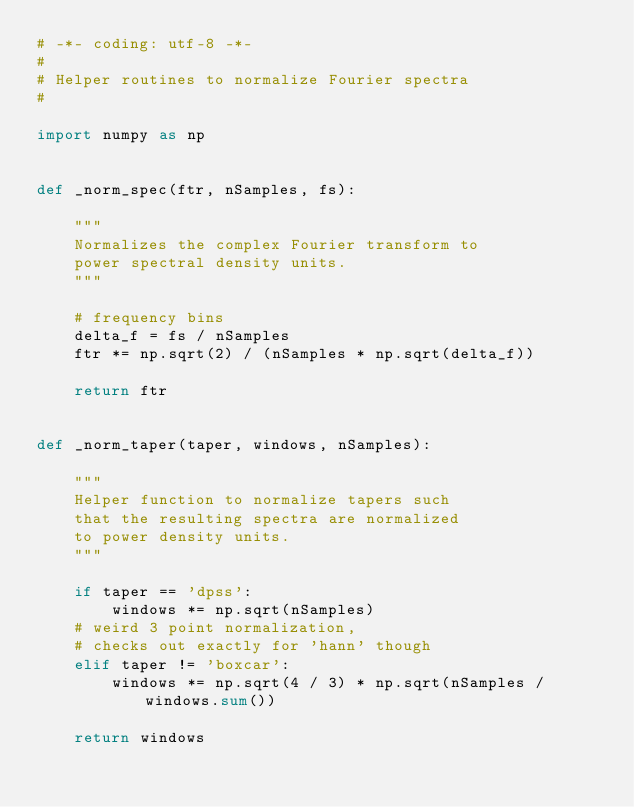Convert code to text. <code><loc_0><loc_0><loc_500><loc_500><_Python_># -*- coding: utf-8 -*-
#
# Helper routines to normalize Fourier spectra
#

import numpy as np


def _norm_spec(ftr, nSamples, fs):

    """
    Normalizes the complex Fourier transform to
    power spectral density units.
    """

    # frequency bins
    delta_f = fs / nSamples
    ftr *= np.sqrt(2) / (nSamples * np.sqrt(delta_f))

    return ftr


def _norm_taper(taper, windows, nSamples):

    """
    Helper function to normalize tapers such
    that the resulting spectra are normalized
    to power density units.
    """

    if taper == 'dpss':
        windows *= np.sqrt(nSamples)
    # weird 3 point normalization,
    # checks out exactly for 'hann' though
    elif taper != 'boxcar':
        windows *= np.sqrt(4 / 3) * np.sqrt(nSamples / windows.sum())

    return windows
</code> 